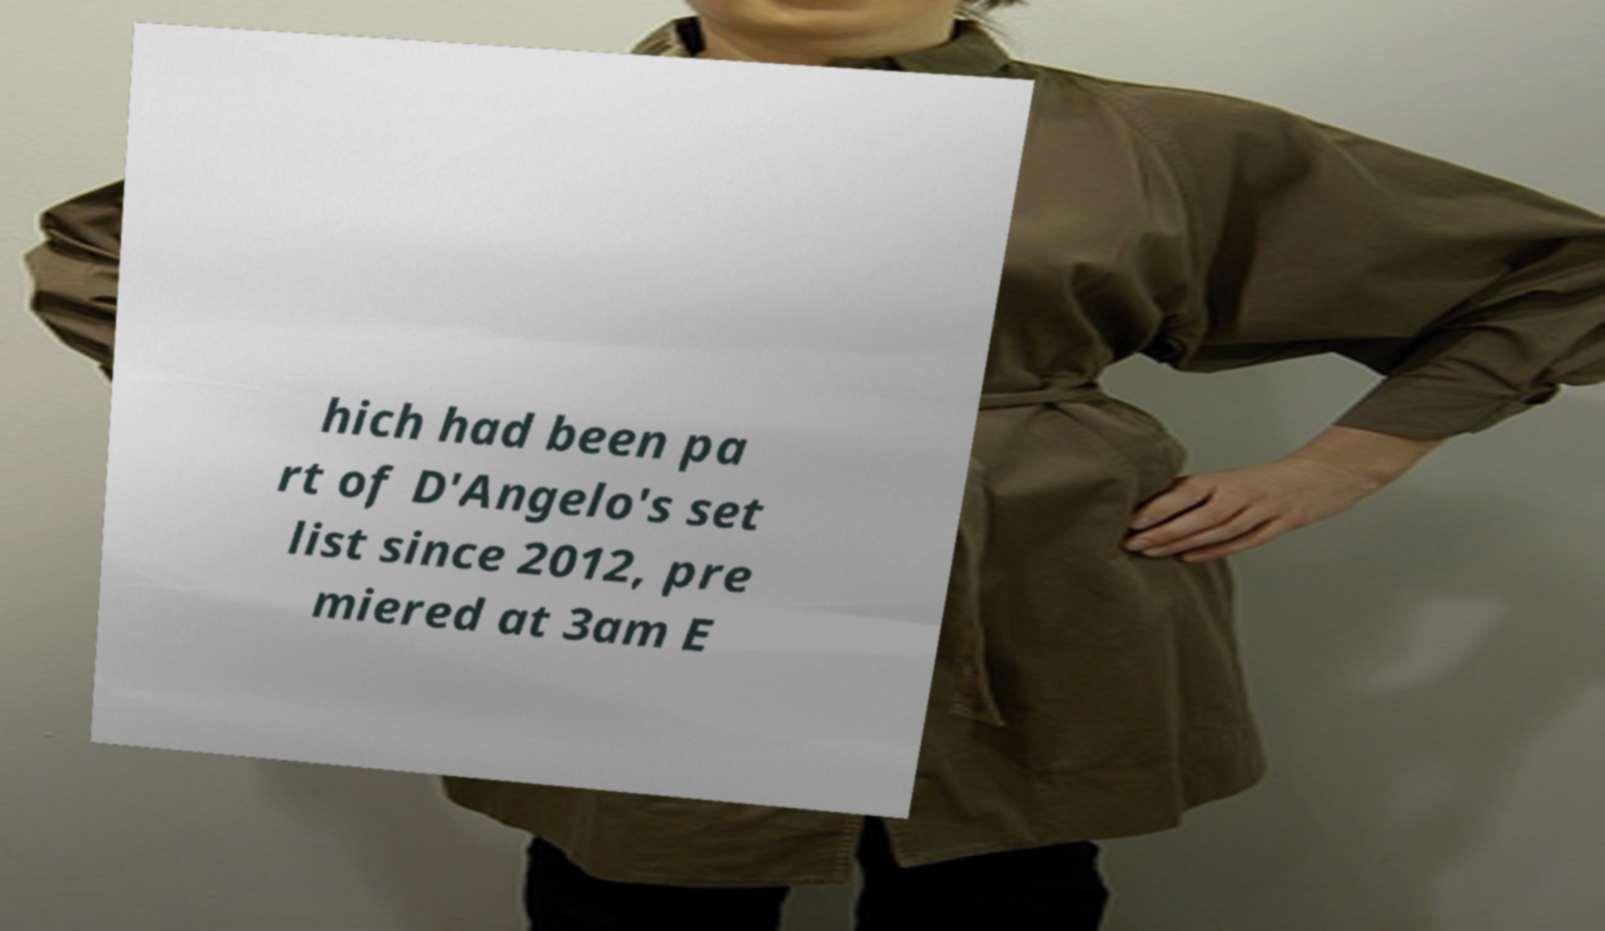Could you assist in decoding the text presented in this image and type it out clearly? hich had been pa rt of D'Angelo's set list since 2012, pre miered at 3am E 